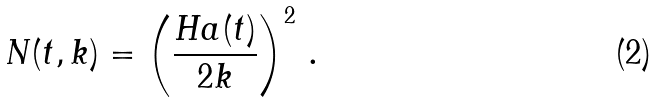Convert formula to latex. <formula><loc_0><loc_0><loc_500><loc_500>N ( t , k ) = \left ( \frac { H a ( t ) } { 2 k } \right ) ^ { 2 } \, .</formula> 